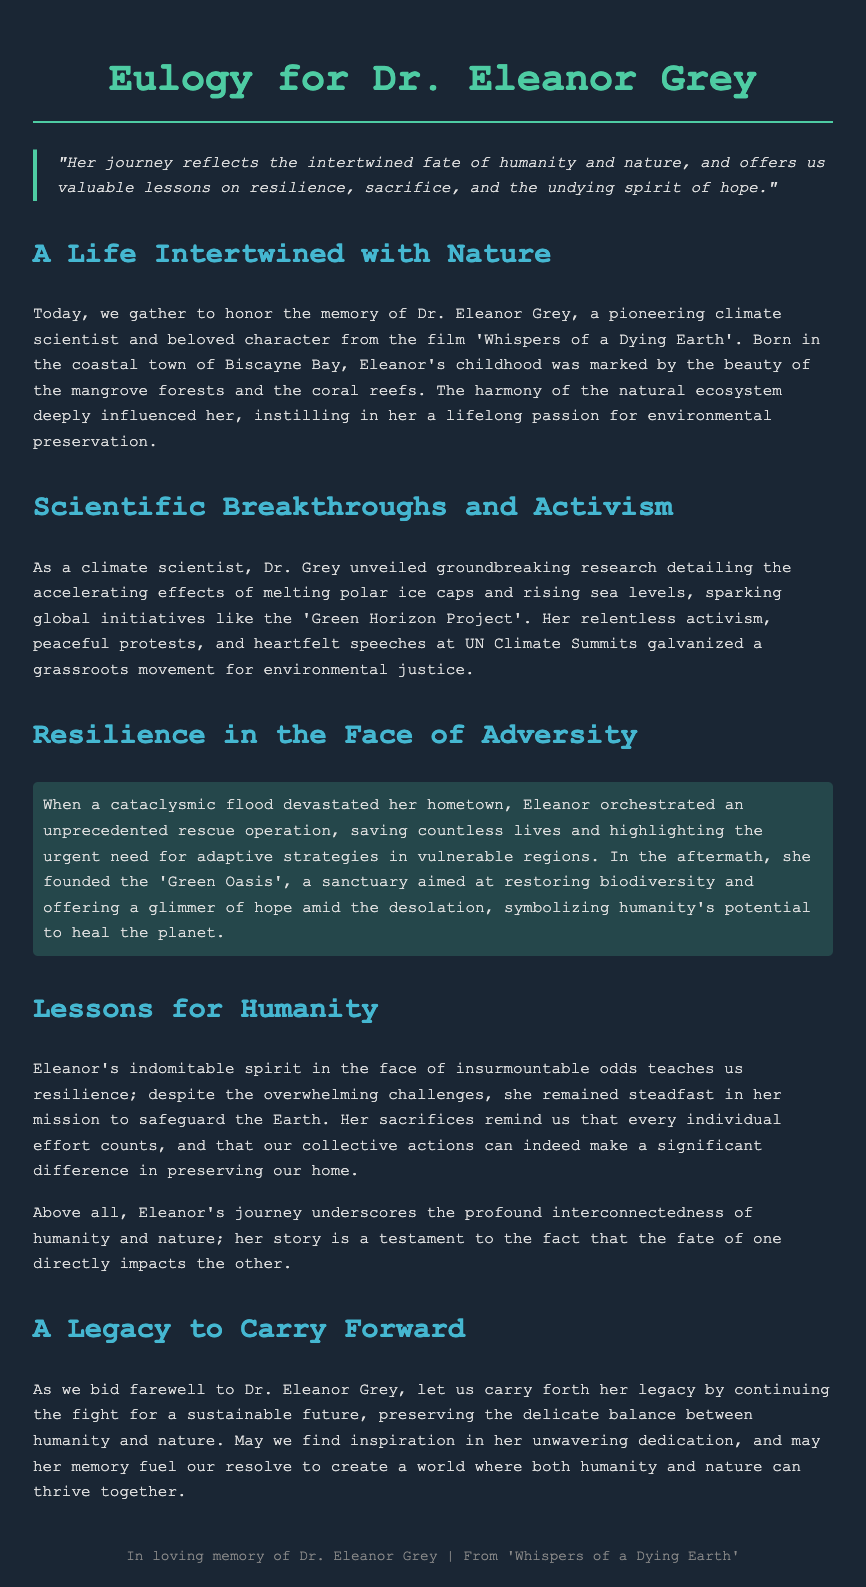What is the name of the character being honored? The eulogy honors Dr. Eleanor Grey, a pioneering climate scientist.
Answer: Dr. Eleanor Grey What is the title of the film Dr. Eleanor Grey is from? The title of the film mentioned in the eulogy is 'Whispers of a Dying Earth'.
Answer: 'Whispers of a Dying Earth' What project did Dr. Grey spark through her research? The groundbreaking research by Dr. Grey initiated the 'Green Horizon Project'.
Answer: 'Green Horizon Project' What natural disaster impacted Eleanor's hometown? The eulogy mentions a cataclysmic flood that devastated her hometown.
Answer: Flood What sanctuary did Dr. Grey found after the flooding? After the flood, she founded the 'Green Oasis', aimed at restoring biodiversity.
Answer: 'Green Oasis' Which qualities of Dr. Eleanor Grey are highlighted in her story? The qualities highlighted in her story include resilience, sacrifice, and hope.
Answer: Resilience, sacrifice, and hope What is the main lesson of Eleanor's journey according to the eulogy? The main lesson of her journey is the interconnectedness of humanity and nature.
Answer: Interconnectedness of humanity and nature What message does the eulogy convey regarding individual efforts? The eulogy emphasizes that every individual effort counts in preserving the Earth.
Answer: Every individual effort counts What should we carry forward as a legacy of Dr. Grey? We should carry forward the fight for a sustainable future as her legacy.
Answer: Fight for a sustainable future 